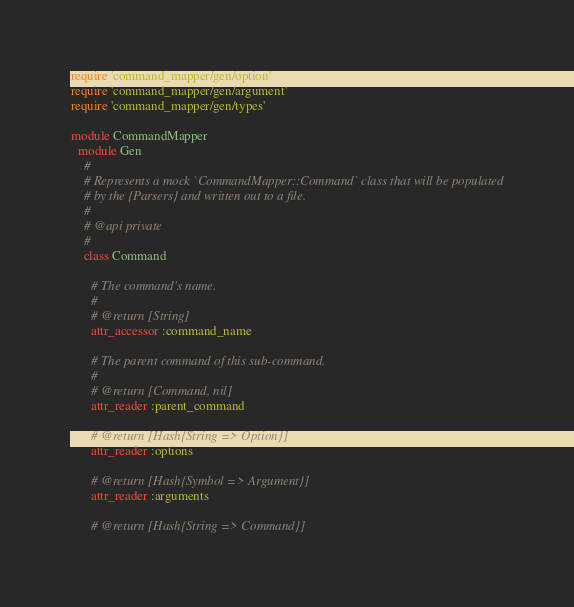Convert code to text. <code><loc_0><loc_0><loc_500><loc_500><_Ruby_>require 'command_mapper/gen/option'
require 'command_mapper/gen/argument'
require 'command_mapper/gen/types'

module CommandMapper
  module Gen
    #
    # Represents a mock `CommandMapper::Command` class that will be populated
    # by the {Parsers} and written out to a file.
    #
    # @api private
    #
    class Command

      # The command's name.
      #
      # @return [String]
      attr_accessor :command_name

      # The parent command of this sub-command.
      #
      # @return [Command, nil]
      attr_reader :parent_command

      # @return [Hash{String => Option}]
      attr_reader :options

      # @return [Hash{Symbol => Argument}]
      attr_reader :arguments

      # @return [Hash{String => Command}]</code> 